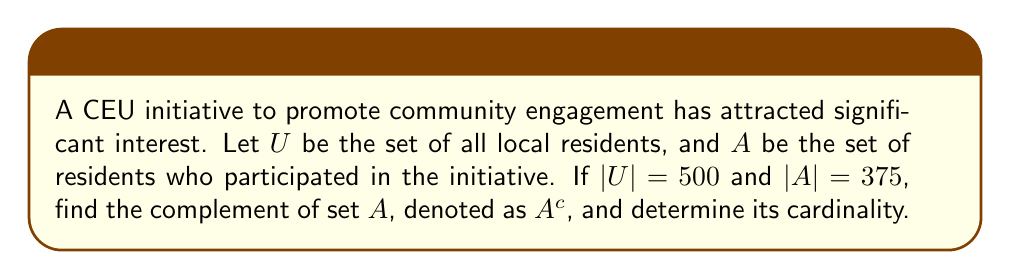Could you help me with this problem? To solve this problem, we need to understand the concept of complement and how to calculate it:

1) The complement of a set $A$, denoted as $A^c$, is the set of all elements in the universal set $U$ that are not in $A$.

2) Mathematically, we can express this as:
   $A^c = U \setminus A$

3) The cardinality of $A^c$ can be calculated using the formula:
   $|A^c| = |U| - |A|$

4) Given:
   $|U| = 500$ (total number of local residents)
   $|A| = 375$ (number of participants in the initiative)

5) Substituting these values into our formula:
   $|A^c| = 500 - 375 = 125$

6) Therefore, the complement of set $A$ (i.e., $A^c$) represents the set of local residents who did not participate in the CEU initiative, and its cardinality is 125.
Answer: $A^c = \{x \in U : x \notin A\}$, where $|A^c| = 125$ 